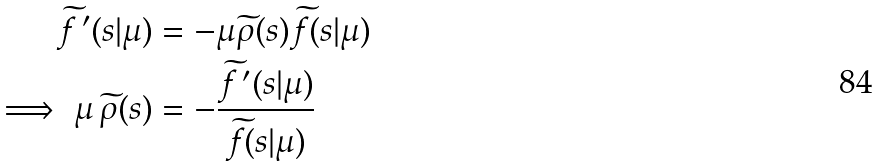Convert formula to latex. <formula><loc_0><loc_0><loc_500><loc_500>\widetilde { f } \, ^ { \prime } ( s | \mu ) & = - \mu \widetilde { \rho } ( s ) \widetilde { f } ( s | \mu ) \\ \implies \mu \, \widetilde { \rho } ( s ) & = - \frac { \widetilde { f } \, ^ { \prime } ( s | \mu ) } { \widetilde { f } ( s | \mu ) }</formula> 